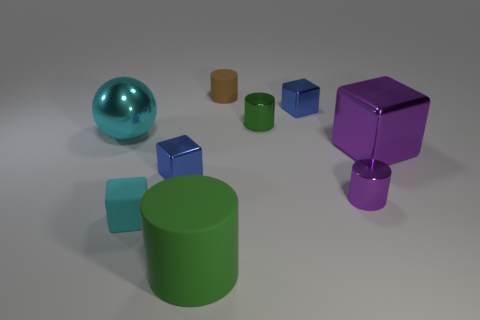Do the large metallic ball and the small matte block have the same color?
Offer a very short reply. Yes. There is a big shiny sphere behind the cyan rubber cube; is it the same color as the small matte block?
Offer a terse response. Yes. There is a metallic thing that is to the left of the tiny rubber cylinder and behind the big purple thing; what is its shape?
Your response must be concise. Sphere. The large metallic thing that is behind the large purple metallic thing is what color?
Provide a succinct answer. Cyan. Is there anything else of the same color as the tiny matte cylinder?
Provide a succinct answer. No. Is the size of the ball the same as the purple metal cube?
Give a very brief answer. Yes. There is a block that is to the left of the purple cube and to the right of the small brown rubber cylinder; how big is it?
Make the answer very short. Small. What number of small objects have the same material as the sphere?
Make the answer very short. 4. There is a small thing that is the same color as the ball; what is its shape?
Your answer should be very brief. Cube. What color is the big cylinder?
Offer a terse response. Green. 